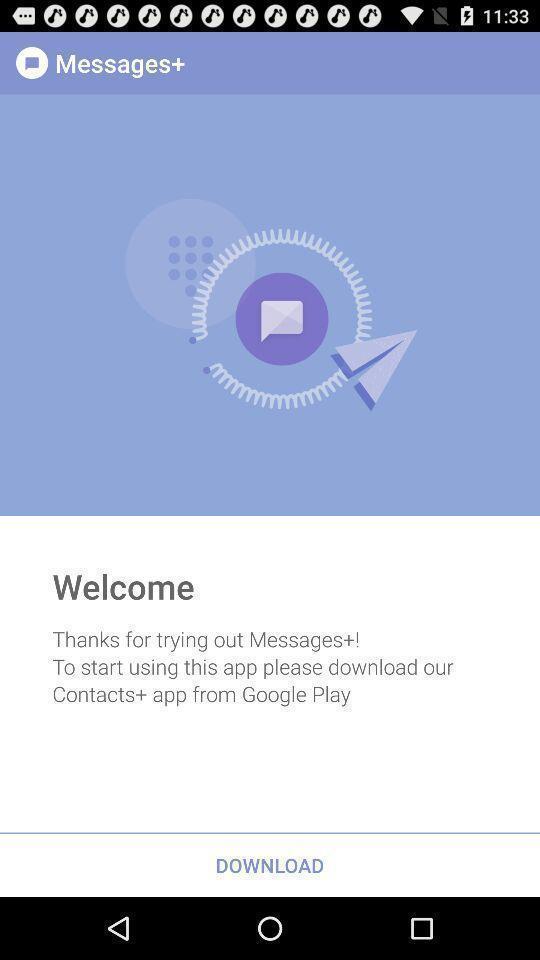Summarize the information in this screenshot. Welcome page. 